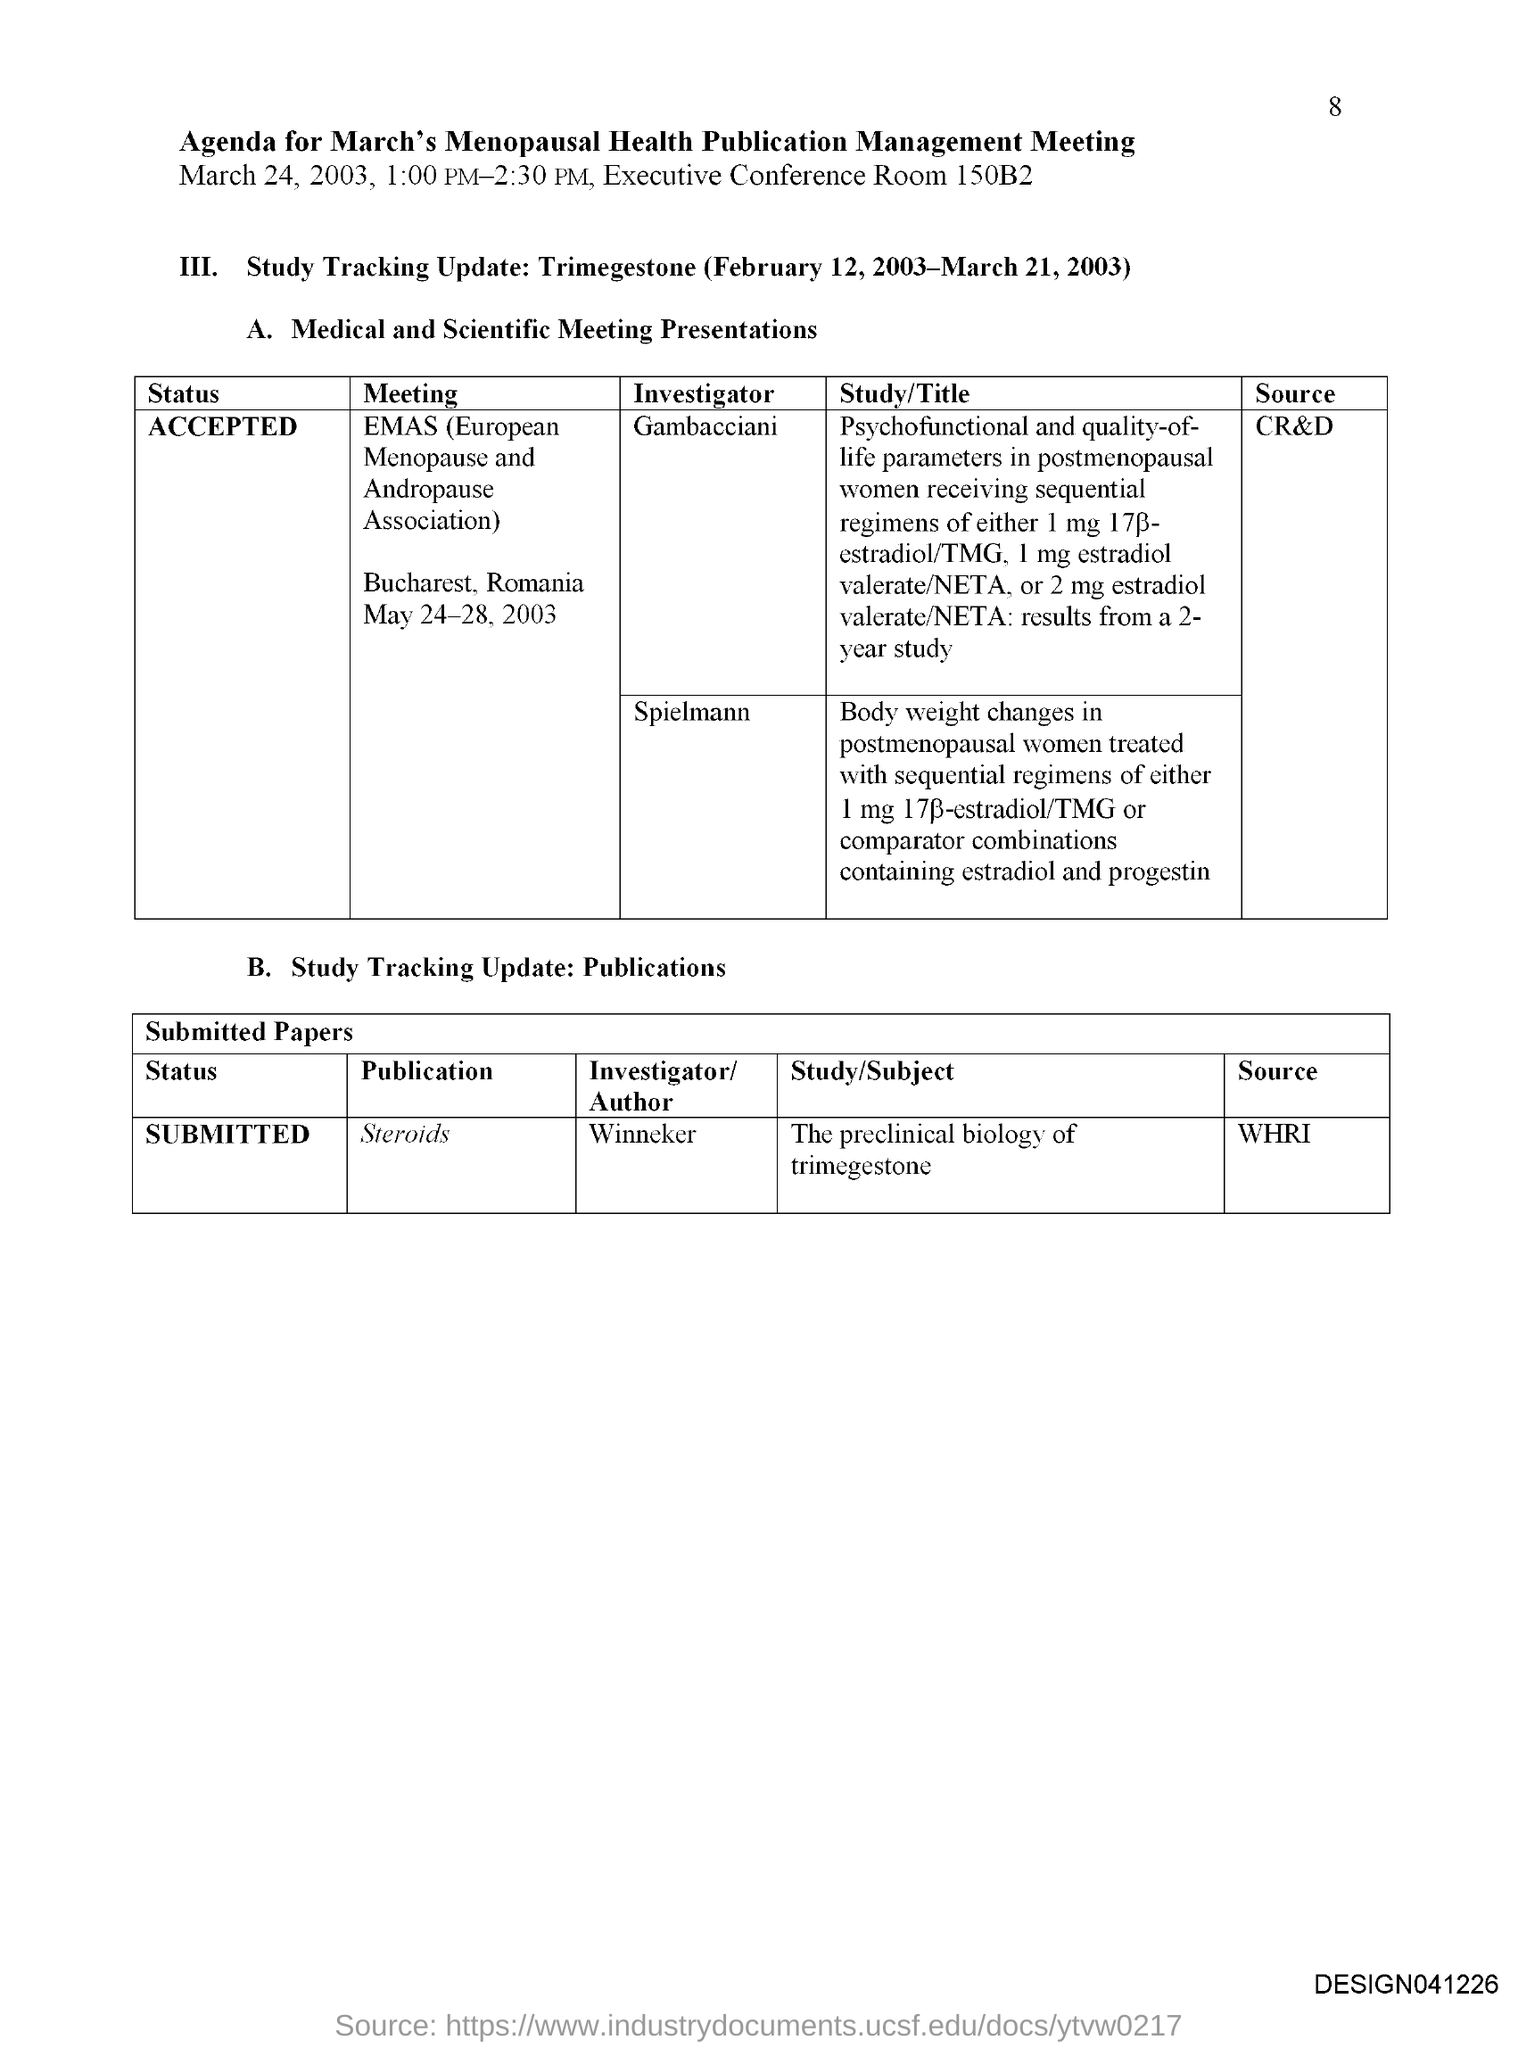What is the Page Number?
Keep it short and to the point. 8. What is the first title in the document?
Offer a terse response. Agenda for march's Menopausal health publication management meeting. What is the room number?
Your answer should be very brief. 150B2. What is the status of the publication "Steroids"?
Your answer should be compact. Submitted. What is the status of the meeting "EMAS"?
Provide a succinct answer. Accepted. What is the source of the publication "Steroids"?
Ensure brevity in your answer.  WHRI. What is the source of the MEETING "EMAS"?
Provide a short and direct response. Cr&d. What is the full form of EMAS?
Provide a short and direct response. European menopause and andropause association. 